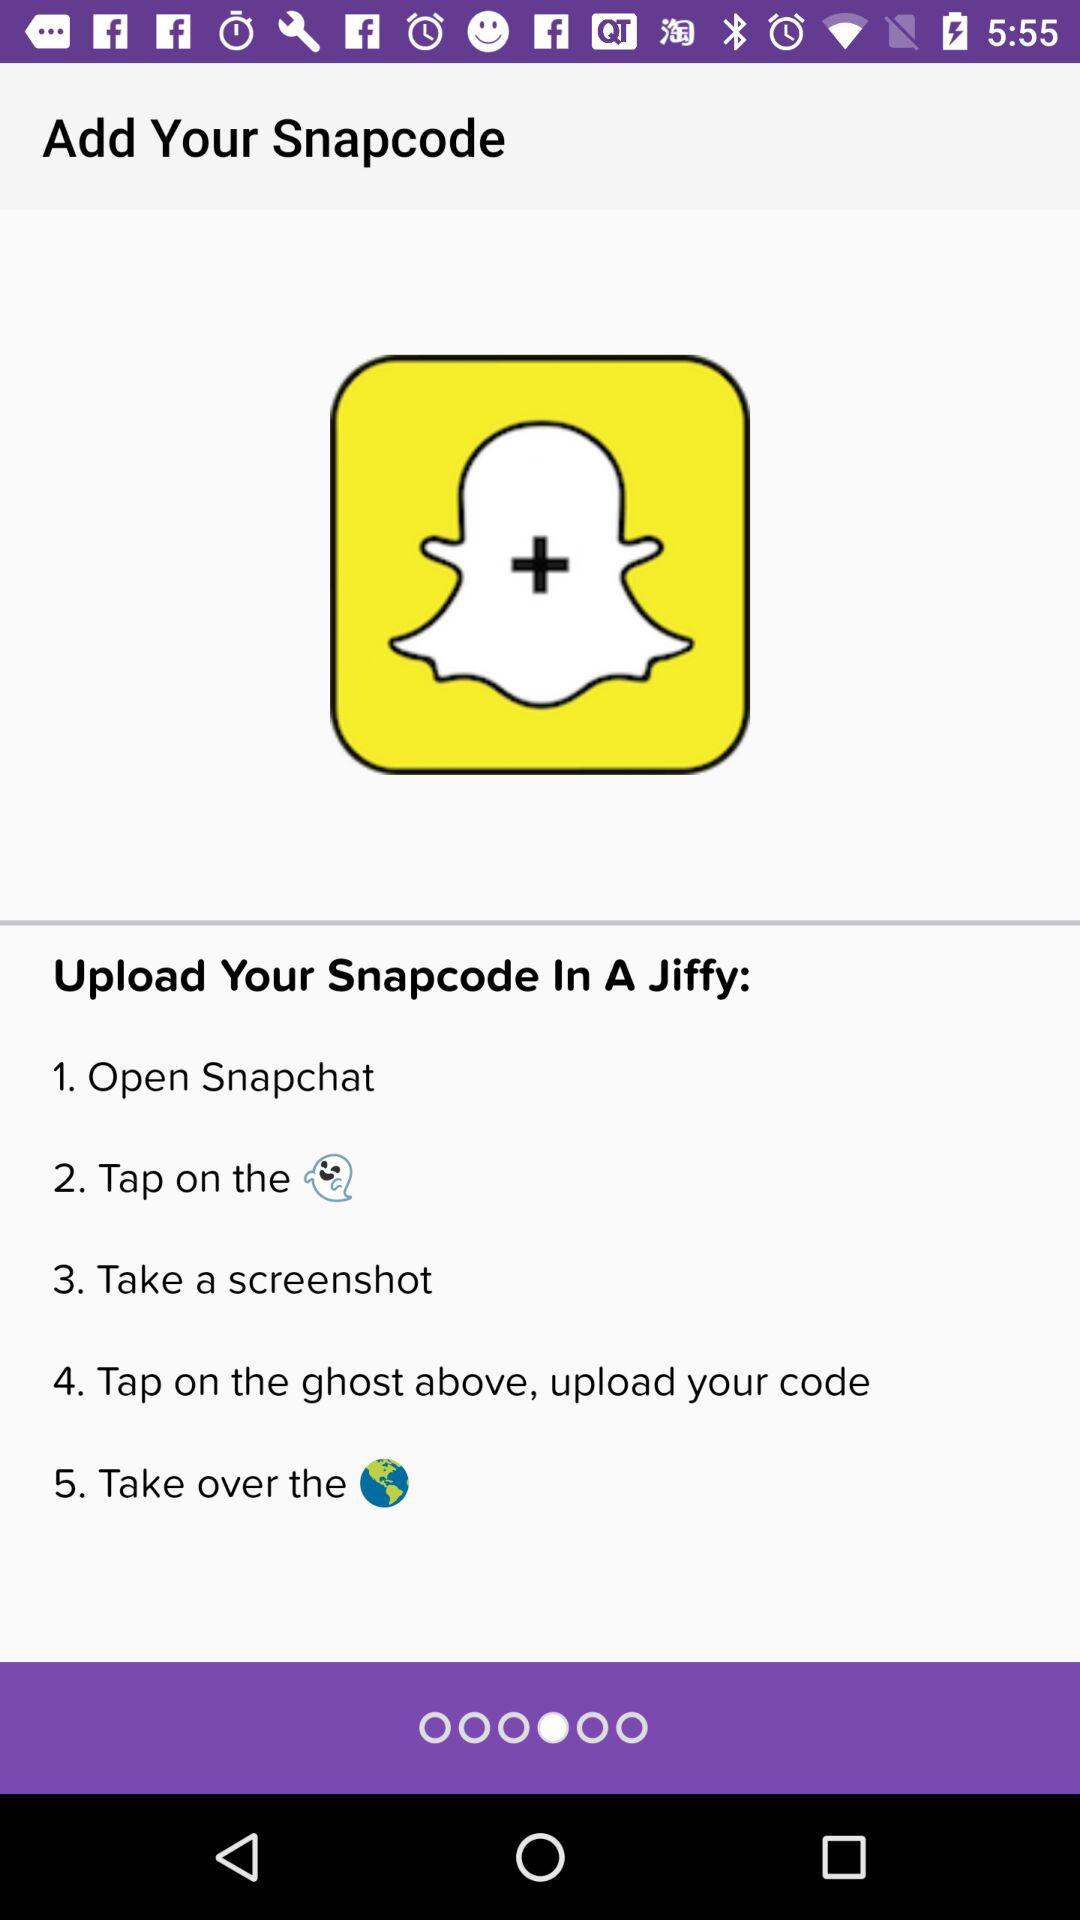What are the steps to add snap code on snapchat?
When the provided information is insufficient, respond with <no answer>. <no answer> 